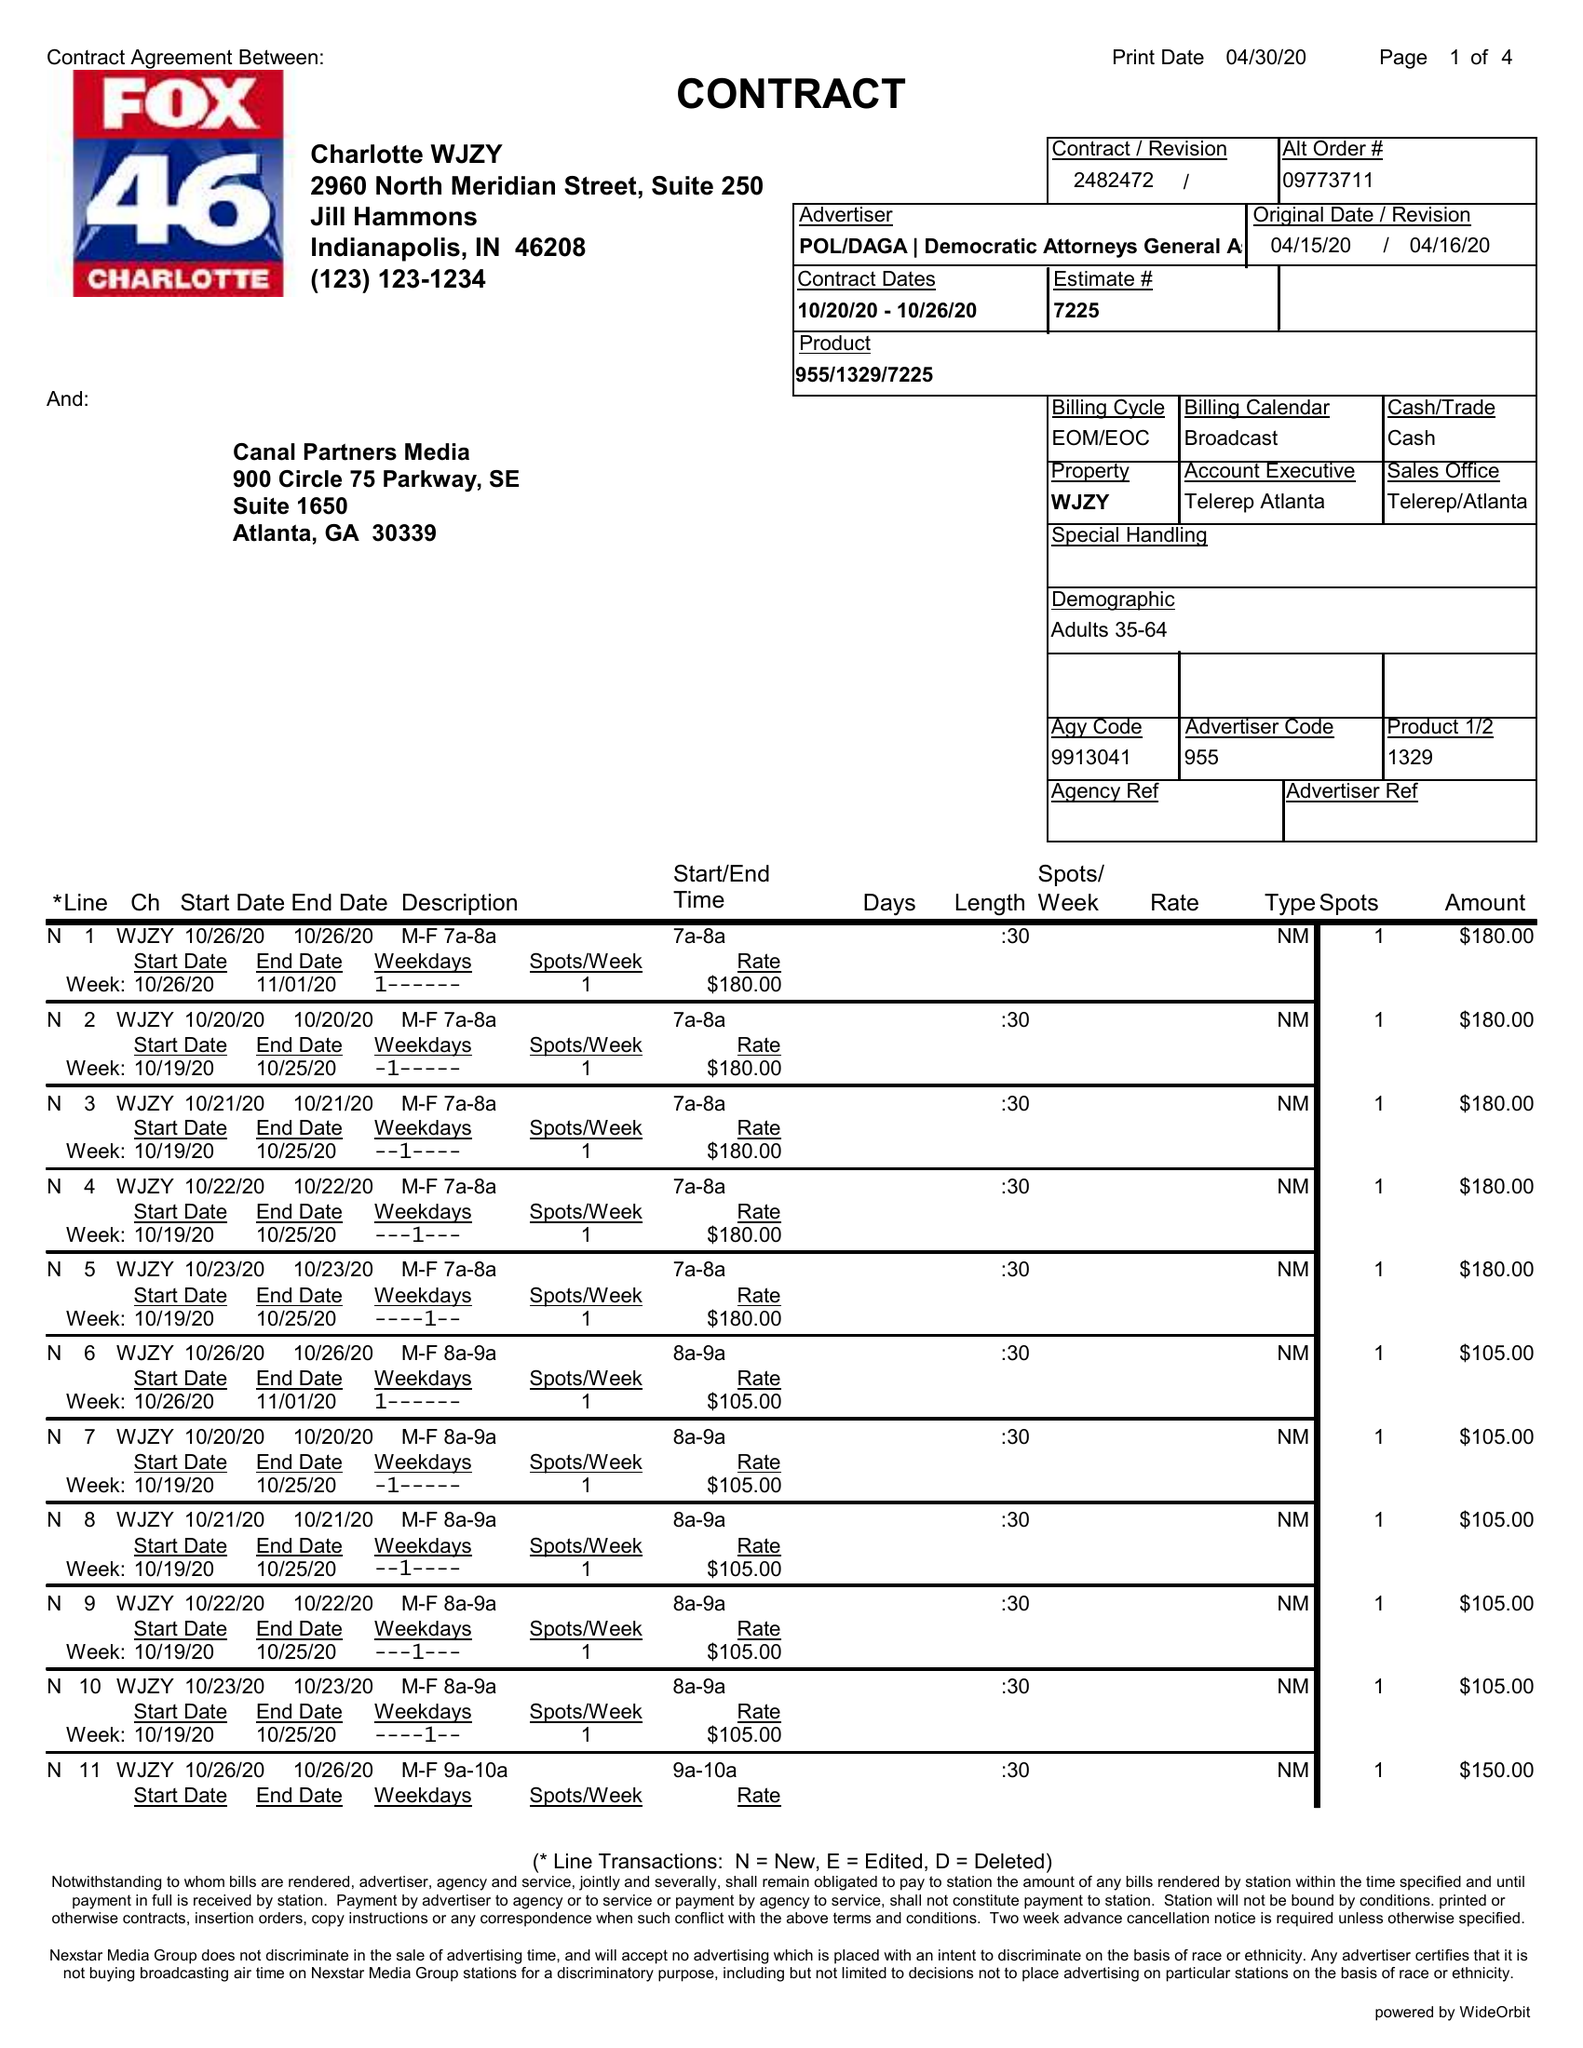What is the value for the flight_to?
Answer the question using a single word or phrase. 10/26/20 